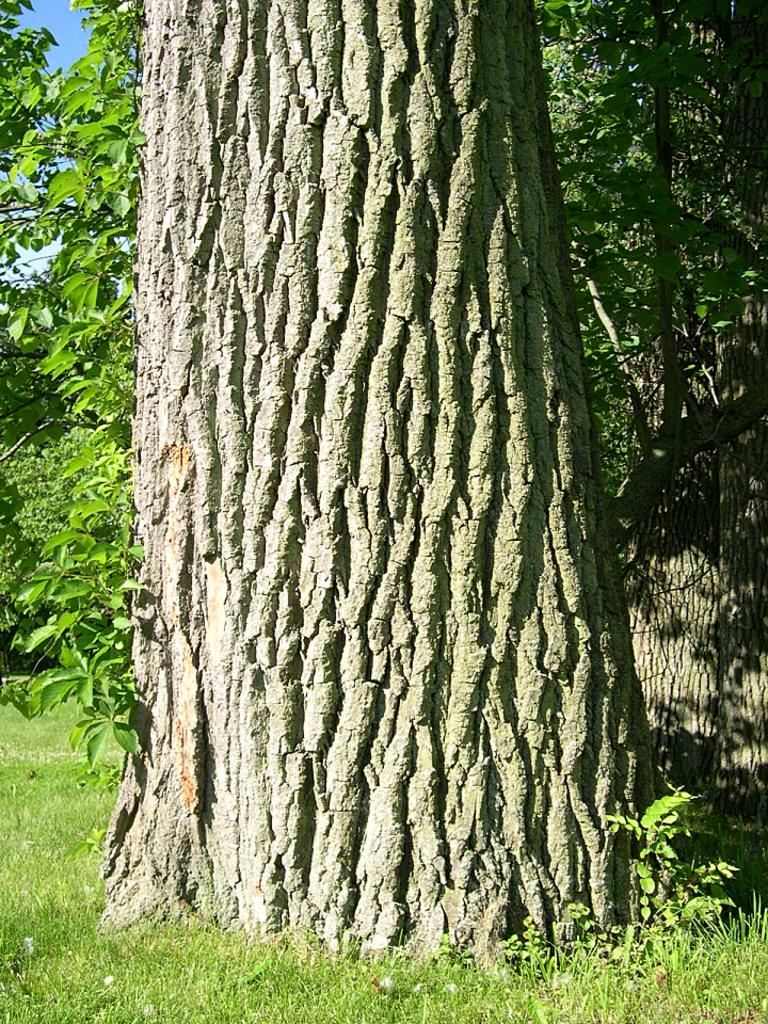What type of natural elements can be seen in the image? Tree trunks, plants, and grass can be seen in the image. Where are the trees located in the image? The trees are in the left side background of the image. What is visible in the background of the image? Trees and the sky are visible in the left side background of the image. What type of steel structure can be seen in the image? There is no steel structure present in the image; it features natural elements such as tree trunks, plants, and grass. What type of prose is being written in the image? There is no writing or prose visible in the image. 